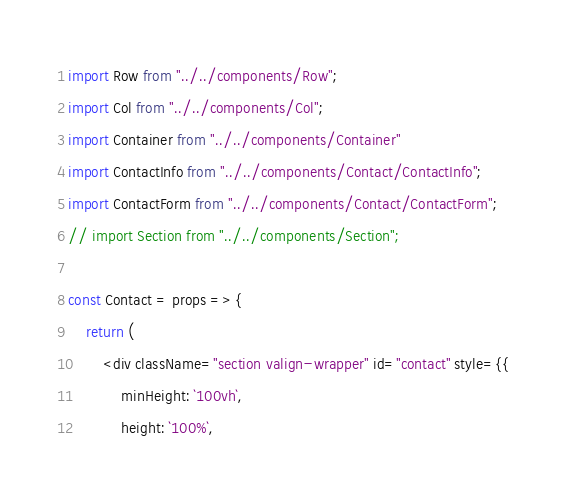Convert code to text. <code><loc_0><loc_0><loc_500><loc_500><_JavaScript_>import Row from "../../components/Row";
import Col from "../../components/Col";
import Container from "../../components/Container"
import ContactInfo from "../../components/Contact/ContactInfo";
import ContactForm from "../../components/Contact/ContactForm";
// import Section from "../../components/Section";

const Contact = props => {
    return (
        <div className="section valign-wrapper" id="contact" style={{
            minHeight: `100vh`,
            height: `100%`,</code> 